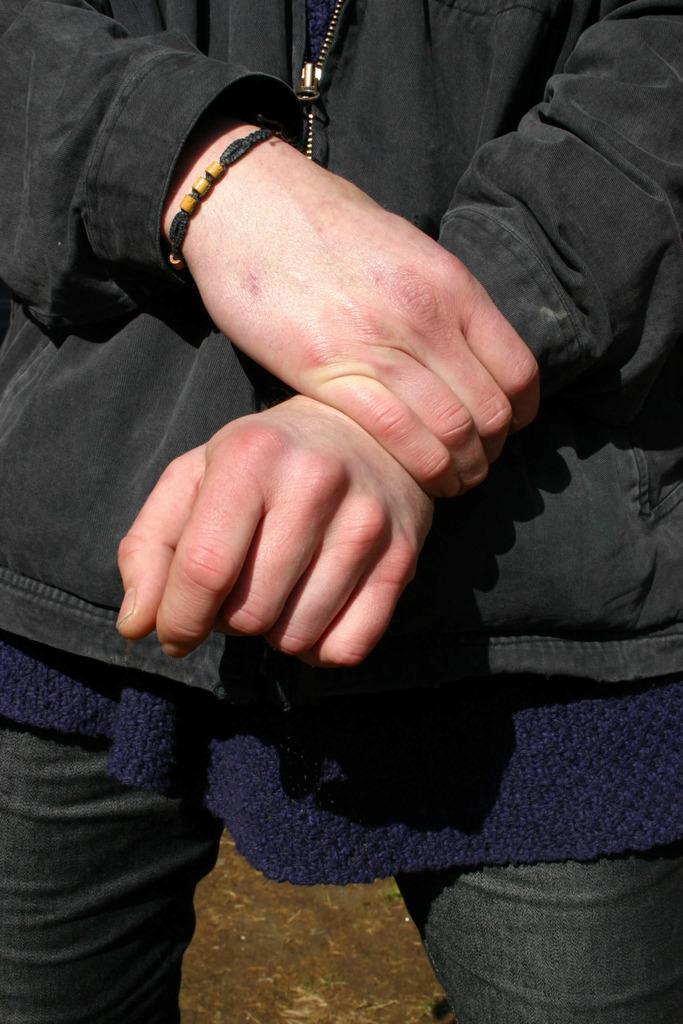Describe this image in one or two sentences. In this image I can see a person standing and wearing black coat and I can see a hand-band. 